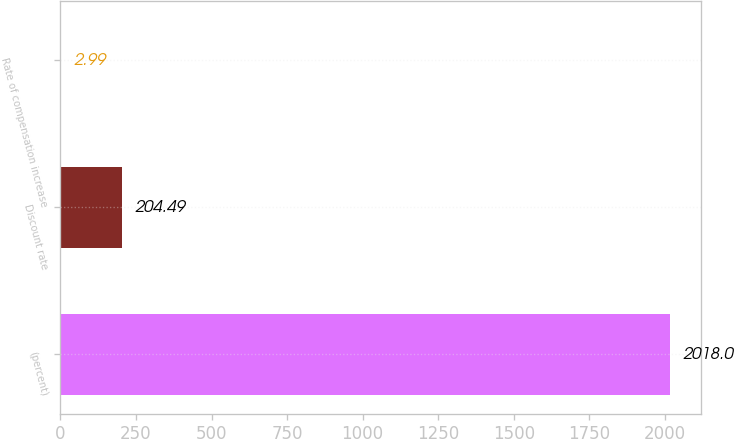Convert chart. <chart><loc_0><loc_0><loc_500><loc_500><bar_chart><fcel>(percent)<fcel>Discount rate<fcel>Rate of compensation increase<nl><fcel>2018<fcel>204.49<fcel>2.99<nl></chart> 